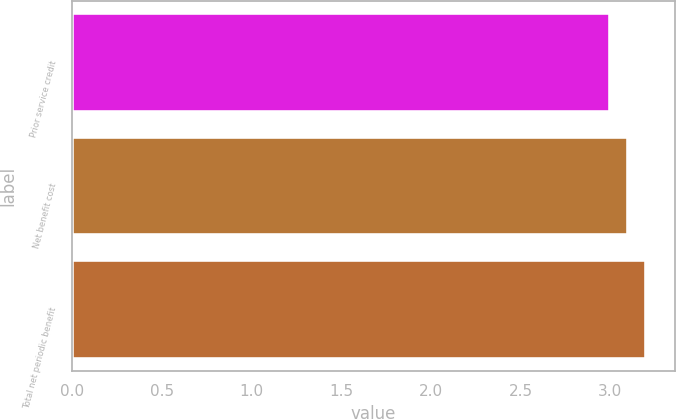<chart> <loc_0><loc_0><loc_500><loc_500><bar_chart><fcel>Prior service credit<fcel>Net benefit cost<fcel>Total net periodic benefit<nl><fcel>3<fcel>3.1<fcel>3.2<nl></chart> 